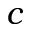Convert formula to latex. <formula><loc_0><loc_0><loc_500><loc_500>c</formula> 